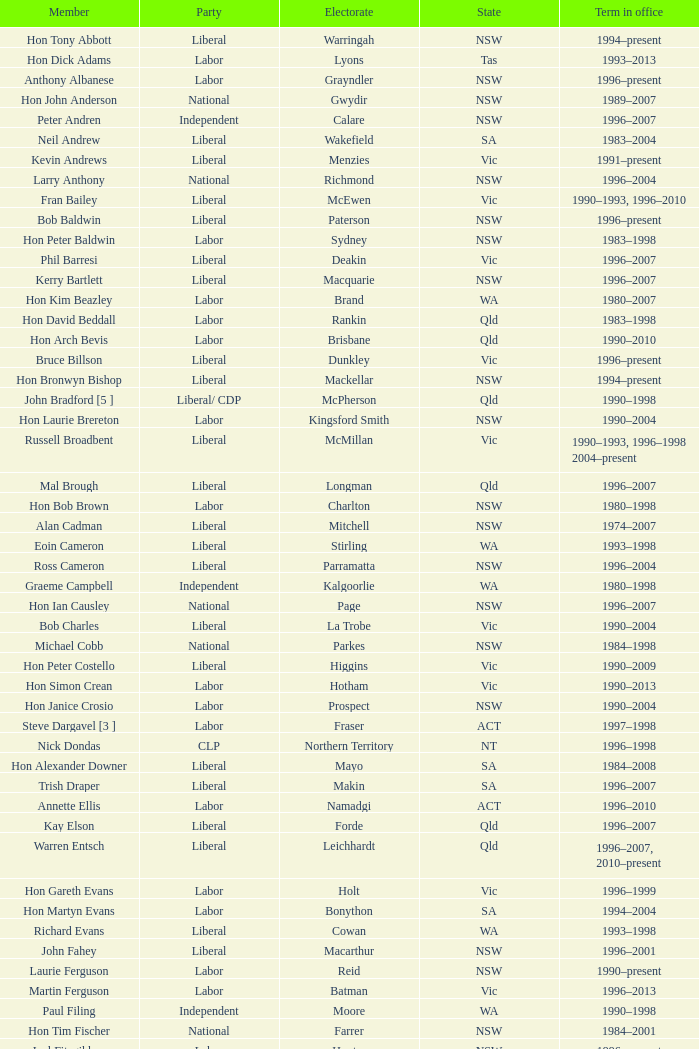In what state was the electorate fowler? NSW. 